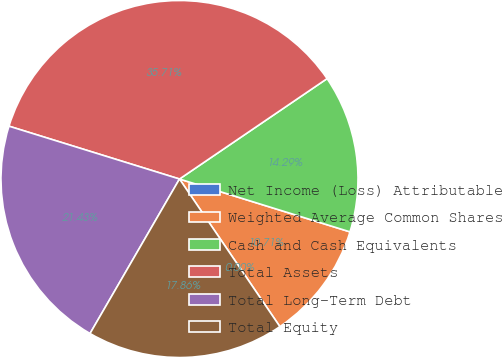Convert chart. <chart><loc_0><loc_0><loc_500><loc_500><pie_chart><fcel>Net Income (Loss) Attributable<fcel>Weighted Average Common Shares<fcel>Cash and Cash Equivalents<fcel>Total Assets<fcel>Total Long-Term Debt<fcel>Total Equity<nl><fcel>0.0%<fcel>10.71%<fcel>14.29%<fcel>35.71%<fcel>21.43%<fcel>17.86%<nl></chart> 